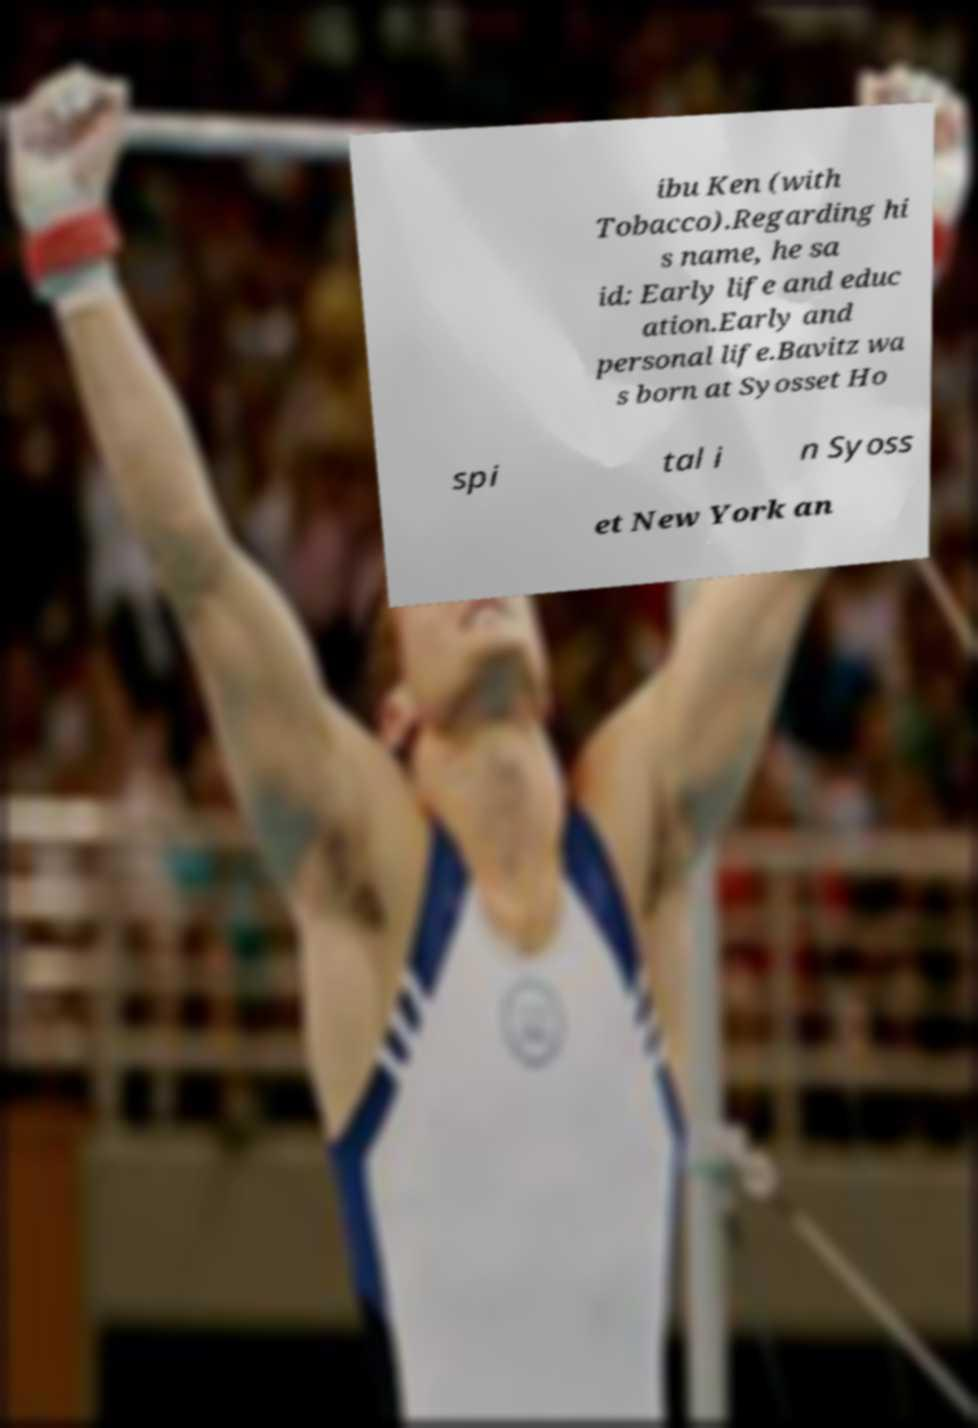Could you assist in decoding the text presented in this image and type it out clearly? ibu Ken (with Tobacco).Regarding hi s name, he sa id: Early life and educ ation.Early and personal life.Bavitz wa s born at Syosset Ho spi tal i n Syoss et New York an 